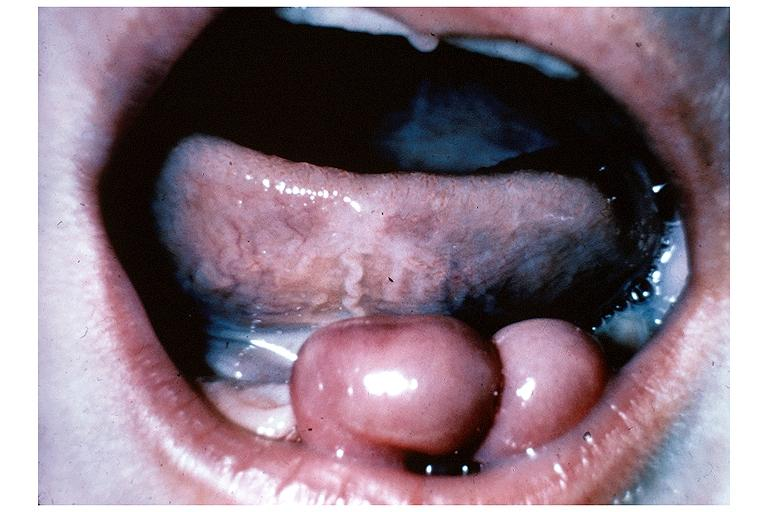does the tumor show congenital epulis?
Answer the question using a single word or phrase. No 